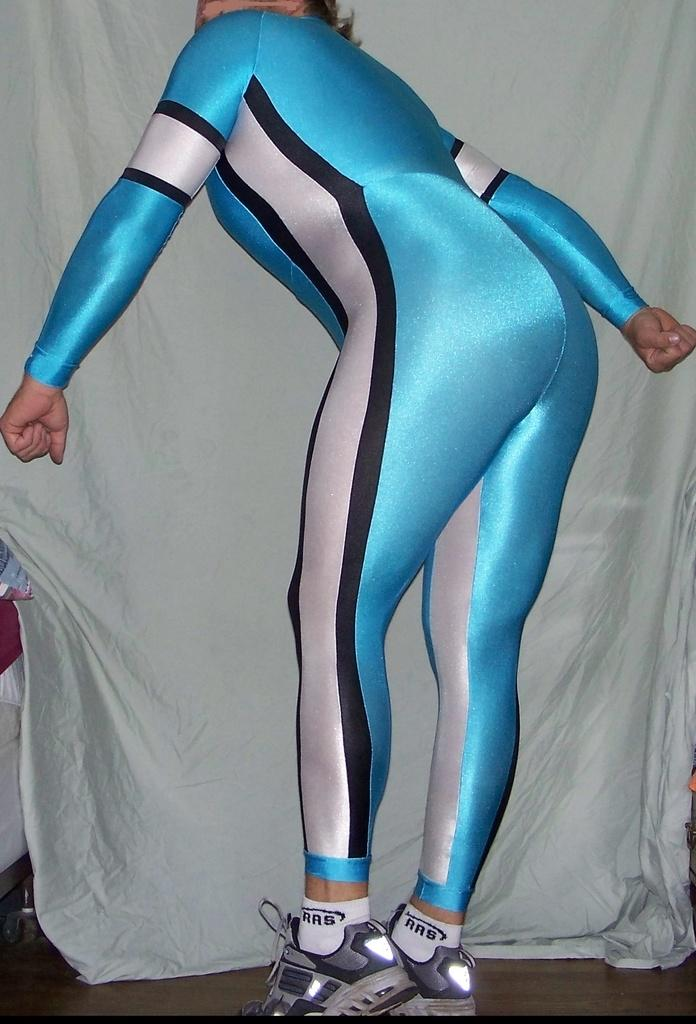<image>
Give a short and clear explanation of the subsequent image. a person in a blue and white cat suit wears RRS branded socks 